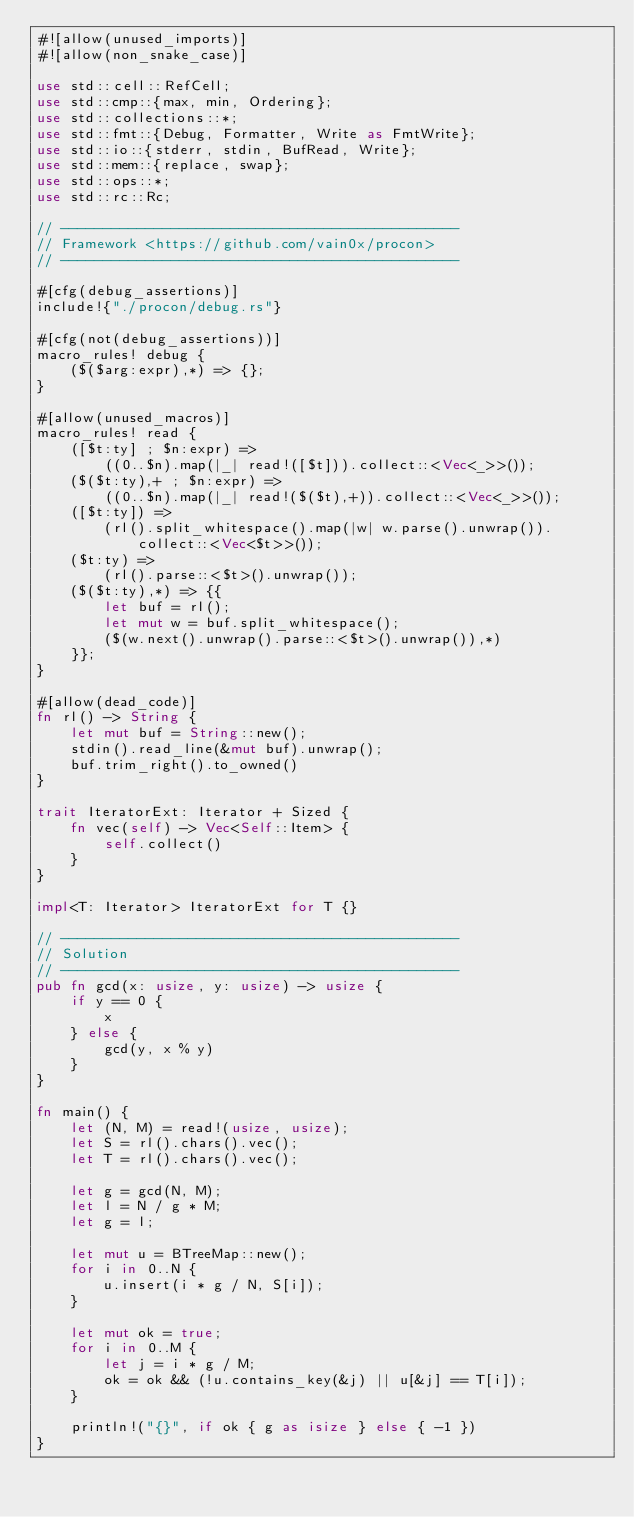Convert code to text. <code><loc_0><loc_0><loc_500><loc_500><_Rust_>#![allow(unused_imports)]
#![allow(non_snake_case)]

use std::cell::RefCell;
use std::cmp::{max, min, Ordering};
use std::collections::*;
use std::fmt::{Debug, Formatter, Write as FmtWrite};
use std::io::{stderr, stdin, BufRead, Write};
use std::mem::{replace, swap};
use std::ops::*;
use std::rc::Rc;

// -----------------------------------------------
// Framework <https://github.com/vain0x/procon>
// -----------------------------------------------

#[cfg(debug_assertions)]
include!{"./procon/debug.rs"}

#[cfg(not(debug_assertions))]
macro_rules! debug {
    ($($arg:expr),*) => {};
}

#[allow(unused_macros)]
macro_rules! read {
    ([$t:ty] ; $n:expr) =>
        ((0..$n).map(|_| read!([$t])).collect::<Vec<_>>());
    ($($t:ty),+ ; $n:expr) =>
        ((0..$n).map(|_| read!($($t),+)).collect::<Vec<_>>());
    ([$t:ty]) =>
        (rl().split_whitespace().map(|w| w.parse().unwrap()).collect::<Vec<$t>>());
    ($t:ty) =>
        (rl().parse::<$t>().unwrap());
    ($($t:ty),*) => {{
        let buf = rl();
        let mut w = buf.split_whitespace();
        ($(w.next().unwrap().parse::<$t>().unwrap()),*)
    }};
}

#[allow(dead_code)]
fn rl() -> String {
    let mut buf = String::new();
    stdin().read_line(&mut buf).unwrap();
    buf.trim_right().to_owned()
}

trait IteratorExt: Iterator + Sized {
    fn vec(self) -> Vec<Self::Item> {
        self.collect()
    }
}

impl<T: Iterator> IteratorExt for T {}

// -----------------------------------------------
// Solution
// -----------------------------------------------
pub fn gcd(x: usize, y: usize) -> usize {
    if y == 0 {
        x
    } else {
        gcd(y, x % y)
    }
}

fn main() {
    let (N, M) = read!(usize, usize);
    let S = rl().chars().vec();
    let T = rl().chars().vec();

    let g = gcd(N, M);
    let l = N / g * M;
    let g = l;

    let mut u = BTreeMap::new();
    for i in 0..N {
        u.insert(i * g / N, S[i]);
    }

    let mut ok = true;
    for i in 0..M {
        let j = i * g / M;
        ok = ok && (!u.contains_key(&j) || u[&j] == T[i]);
    }

    println!("{}", if ok { g as isize } else { -1 })
}
</code> 